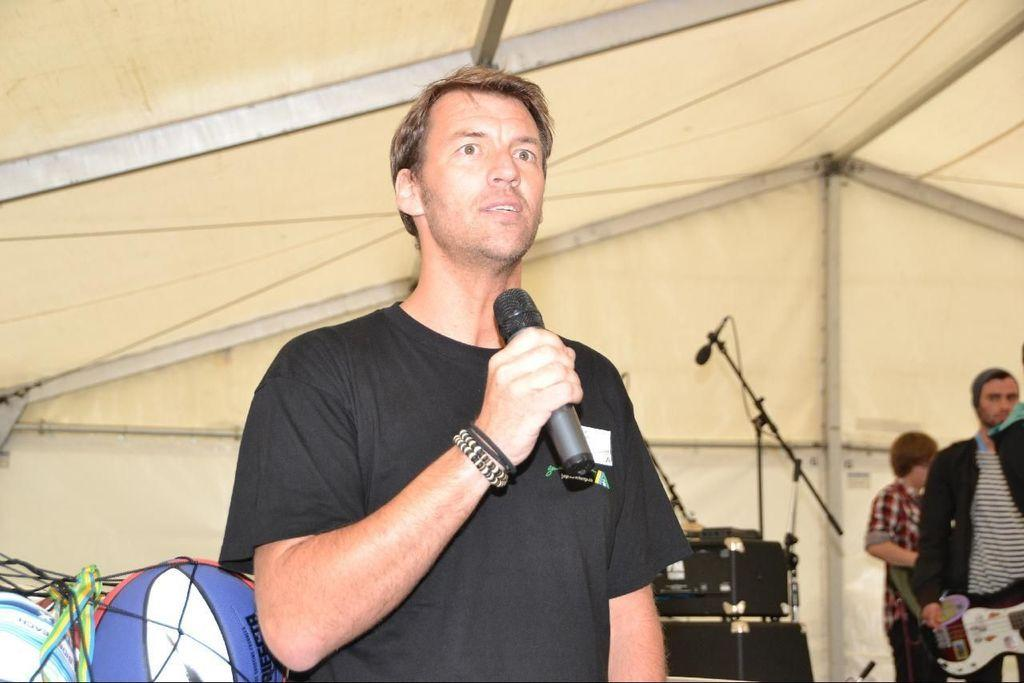What is the main subject of the image? There is a person standing in the center of the image. What is the person in the center holding? The person is holding a microphone in his hand. What is the person in the center doing? The person is speaking. How many other people are visible in the image? There are two persons on the right side of the image. What type of pets are visible in the image? There are no pets visible in the image. How many times has the person in the center twisted the microphone? The image does not provide information about the person twisting the microphone, so it cannot be determined. 